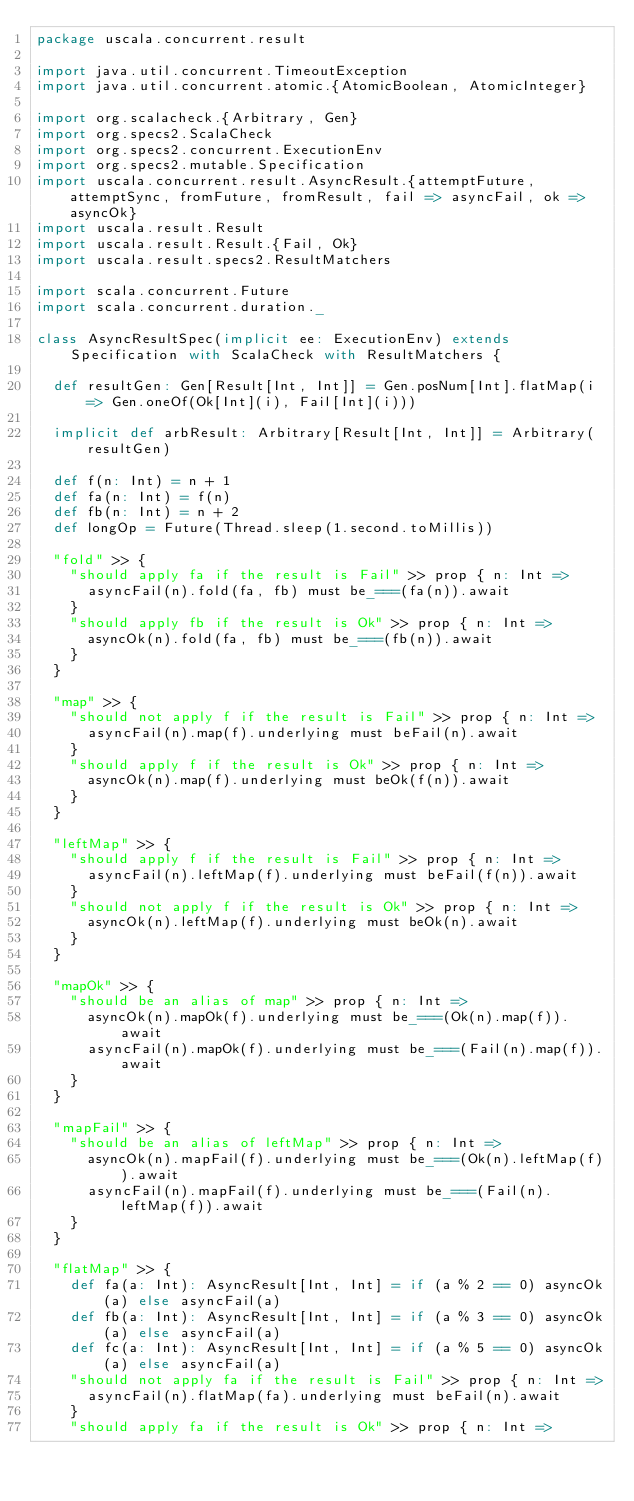<code> <loc_0><loc_0><loc_500><loc_500><_Scala_>package uscala.concurrent.result

import java.util.concurrent.TimeoutException
import java.util.concurrent.atomic.{AtomicBoolean, AtomicInteger}

import org.scalacheck.{Arbitrary, Gen}
import org.specs2.ScalaCheck
import org.specs2.concurrent.ExecutionEnv
import org.specs2.mutable.Specification
import uscala.concurrent.result.AsyncResult.{attemptFuture, attemptSync, fromFuture, fromResult, fail => asyncFail, ok => asyncOk}
import uscala.result.Result
import uscala.result.Result.{Fail, Ok}
import uscala.result.specs2.ResultMatchers

import scala.concurrent.Future
import scala.concurrent.duration._

class AsyncResultSpec(implicit ee: ExecutionEnv) extends Specification with ScalaCheck with ResultMatchers {

  def resultGen: Gen[Result[Int, Int]] = Gen.posNum[Int].flatMap(i => Gen.oneOf(Ok[Int](i), Fail[Int](i)))

  implicit def arbResult: Arbitrary[Result[Int, Int]] = Arbitrary(resultGen)

  def f(n: Int) = n + 1
  def fa(n: Int) = f(n)
  def fb(n: Int) = n + 2
  def longOp = Future(Thread.sleep(1.second.toMillis))

  "fold" >> {
    "should apply fa if the result is Fail" >> prop { n: Int =>
      asyncFail(n).fold(fa, fb) must be_===(fa(n)).await
    }
    "should apply fb if the result is Ok" >> prop { n: Int =>
      asyncOk(n).fold(fa, fb) must be_===(fb(n)).await
    }
  }

  "map" >> {
    "should not apply f if the result is Fail" >> prop { n: Int =>
      asyncFail(n).map(f).underlying must beFail(n).await
    }
    "should apply f if the result is Ok" >> prop { n: Int =>
      asyncOk(n).map(f).underlying must beOk(f(n)).await
    }
  }

  "leftMap" >> {
    "should apply f if the result is Fail" >> prop { n: Int =>
      asyncFail(n).leftMap(f).underlying must beFail(f(n)).await
    }
    "should not apply f if the result is Ok" >> prop { n: Int =>
      asyncOk(n).leftMap(f).underlying must beOk(n).await
    }
  }

  "mapOk" >> {
    "should be an alias of map" >> prop { n: Int =>
      asyncOk(n).mapOk(f).underlying must be_===(Ok(n).map(f)).await
      asyncFail(n).mapOk(f).underlying must be_===(Fail(n).map(f)).await
    }
  }

  "mapFail" >> {
    "should be an alias of leftMap" >> prop { n: Int =>
      asyncOk(n).mapFail(f).underlying must be_===(Ok(n).leftMap(f)).await
      asyncFail(n).mapFail(f).underlying must be_===(Fail(n).leftMap(f)).await
    }
  }

  "flatMap" >> {
    def fa(a: Int): AsyncResult[Int, Int] = if (a % 2 == 0) asyncOk(a) else asyncFail(a)
    def fb(a: Int): AsyncResult[Int, Int] = if (a % 3 == 0) asyncOk(a) else asyncFail(a)
    def fc(a: Int): AsyncResult[Int, Int] = if (a % 5 == 0) asyncOk(a) else asyncFail(a)
    "should not apply fa if the result is Fail" >> prop { n: Int =>
      asyncFail(n).flatMap(fa).underlying must beFail(n).await
    }
    "should apply fa if the result is Ok" >> prop { n: Int =></code> 